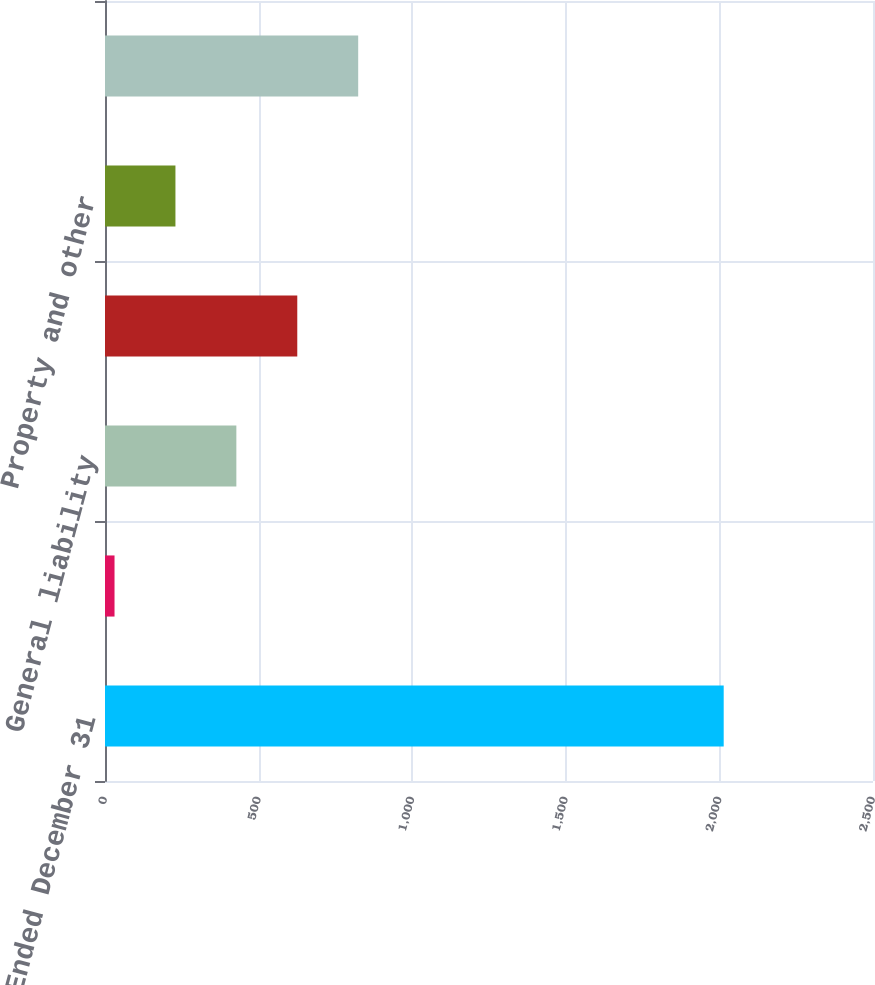Convert chart. <chart><loc_0><loc_0><loc_500><loc_500><bar_chart><fcel>Year Ended December 31<fcel>Commercial auto<fcel>General liability<fcel>Workers' compensation<fcel>Property and other<fcel>Total pretax (favorable)<nl><fcel>2014<fcel>31<fcel>427.6<fcel>625.9<fcel>229.3<fcel>824.2<nl></chart> 